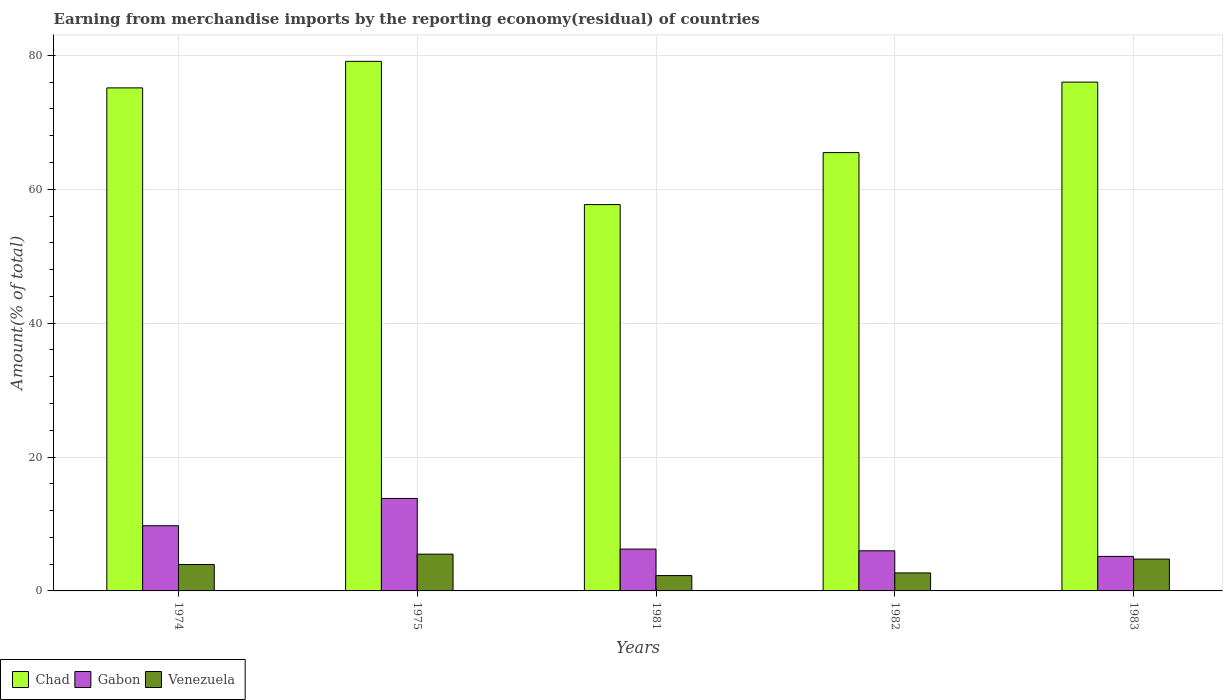How many groups of bars are there?
Offer a terse response. 5. Are the number of bars per tick equal to the number of legend labels?
Make the answer very short. Yes. How many bars are there on the 5th tick from the left?
Make the answer very short. 3. How many bars are there on the 4th tick from the right?
Offer a very short reply. 3. What is the label of the 4th group of bars from the left?
Your response must be concise. 1982. In how many cases, is the number of bars for a given year not equal to the number of legend labels?
Your response must be concise. 0. What is the percentage of amount earned from merchandise imports in Gabon in 1983?
Offer a terse response. 5.16. Across all years, what is the maximum percentage of amount earned from merchandise imports in Venezuela?
Give a very brief answer. 5.49. Across all years, what is the minimum percentage of amount earned from merchandise imports in Chad?
Give a very brief answer. 57.71. In which year was the percentage of amount earned from merchandise imports in Chad maximum?
Your answer should be very brief. 1975. What is the total percentage of amount earned from merchandise imports in Gabon in the graph?
Give a very brief answer. 40.95. What is the difference between the percentage of amount earned from merchandise imports in Chad in 1982 and that in 1983?
Give a very brief answer. -10.53. What is the difference between the percentage of amount earned from merchandise imports in Venezuela in 1975 and the percentage of amount earned from merchandise imports in Chad in 1983?
Keep it short and to the point. -70.51. What is the average percentage of amount earned from merchandise imports in Venezuela per year?
Give a very brief answer. 3.83. In the year 1982, what is the difference between the percentage of amount earned from merchandise imports in Gabon and percentage of amount earned from merchandise imports in Venezuela?
Provide a succinct answer. 3.3. What is the ratio of the percentage of amount earned from merchandise imports in Chad in 1981 to that in 1982?
Keep it short and to the point. 0.88. Is the difference between the percentage of amount earned from merchandise imports in Gabon in 1974 and 1981 greater than the difference between the percentage of amount earned from merchandise imports in Venezuela in 1974 and 1981?
Make the answer very short. Yes. What is the difference between the highest and the second highest percentage of amount earned from merchandise imports in Gabon?
Offer a terse response. 4.08. What is the difference between the highest and the lowest percentage of amount earned from merchandise imports in Venezuela?
Provide a short and direct response. 3.2. Is the sum of the percentage of amount earned from merchandise imports in Chad in 1974 and 1982 greater than the maximum percentage of amount earned from merchandise imports in Venezuela across all years?
Your response must be concise. Yes. What does the 3rd bar from the left in 1975 represents?
Offer a terse response. Venezuela. What does the 3rd bar from the right in 1981 represents?
Your response must be concise. Chad. How many bars are there?
Ensure brevity in your answer.  15. Are all the bars in the graph horizontal?
Offer a very short reply. No. How are the legend labels stacked?
Offer a terse response. Horizontal. What is the title of the graph?
Your answer should be very brief. Earning from merchandise imports by the reporting economy(residual) of countries. What is the label or title of the Y-axis?
Your answer should be very brief. Amount(% of total). What is the Amount(% of total) in Chad in 1974?
Your answer should be compact. 75.14. What is the Amount(% of total) in Gabon in 1974?
Your response must be concise. 9.74. What is the Amount(% of total) in Venezuela in 1974?
Offer a very short reply. 3.94. What is the Amount(% of total) of Chad in 1975?
Keep it short and to the point. 79.1. What is the Amount(% of total) of Gabon in 1975?
Your response must be concise. 13.81. What is the Amount(% of total) in Venezuela in 1975?
Give a very brief answer. 5.49. What is the Amount(% of total) in Chad in 1981?
Provide a succinct answer. 57.71. What is the Amount(% of total) of Gabon in 1981?
Give a very brief answer. 6.25. What is the Amount(% of total) of Venezuela in 1981?
Provide a succinct answer. 2.29. What is the Amount(% of total) in Chad in 1982?
Your answer should be very brief. 65.47. What is the Amount(% of total) in Gabon in 1982?
Provide a short and direct response. 5.99. What is the Amount(% of total) of Venezuela in 1982?
Give a very brief answer. 2.69. What is the Amount(% of total) in Chad in 1983?
Offer a very short reply. 76. What is the Amount(% of total) in Gabon in 1983?
Your answer should be compact. 5.16. What is the Amount(% of total) in Venezuela in 1983?
Make the answer very short. 4.75. Across all years, what is the maximum Amount(% of total) of Chad?
Your response must be concise. 79.1. Across all years, what is the maximum Amount(% of total) in Gabon?
Offer a terse response. 13.81. Across all years, what is the maximum Amount(% of total) of Venezuela?
Provide a short and direct response. 5.49. Across all years, what is the minimum Amount(% of total) in Chad?
Ensure brevity in your answer.  57.71. Across all years, what is the minimum Amount(% of total) of Gabon?
Your answer should be very brief. 5.16. Across all years, what is the minimum Amount(% of total) of Venezuela?
Your response must be concise. 2.29. What is the total Amount(% of total) of Chad in the graph?
Make the answer very short. 353.42. What is the total Amount(% of total) in Gabon in the graph?
Offer a very short reply. 40.95. What is the total Amount(% of total) of Venezuela in the graph?
Provide a short and direct response. 19.17. What is the difference between the Amount(% of total) in Chad in 1974 and that in 1975?
Your answer should be very brief. -3.96. What is the difference between the Amount(% of total) in Gabon in 1974 and that in 1975?
Give a very brief answer. -4.08. What is the difference between the Amount(% of total) in Venezuela in 1974 and that in 1975?
Offer a very short reply. -1.55. What is the difference between the Amount(% of total) of Chad in 1974 and that in 1981?
Your answer should be compact. 17.43. What is the difference between the Amount(% of total) in Gabon in 1974 and that in 1981?
Ensure brevity in your answer.  3.49. What is the difference between the Amount(% of total) of Venezuela in 1974 and that in 1981?
Make the answer very short. 1.65. What is the difference between the Amount(% of total) in Chad in 1974 and that in 1982?
Your answer should be compact. 9.67. What is the difference between the Amount(% of total) in Gabon in 1974 and that in 1982?
Your answer should be compact. 3.75. What is the difference between the Amount(% of total) in Venezuela in 1974 and that in 1982?
Provide a short and direct response. 1.26. What is the difference between the Amount(% of total) of Chad in 1974 and that in 1983?
Offer a terse response. -0.86. What is the difference between the Amount(% of total) in Gabon in 1974 and that in 1983?
Keep it short and to the point. 4.58. What is the difference between the Amount(% of total) of Venezuela in 1974 and that in 1983?
Keep it short and to the point. -0.81. What is the difference between the Amount(% of total) of Chad in 1975 and that in 1981?
Ensure brevity in your answer.  21.39. What is the difference between the Amount(% of total) in Gabon in 1975 and that in 1981?
Give a very brief answer. 7.56. What is the difference between the Amount(% of total) of Venezuela in 1975 and that in 1981?
Your answer should be very brief. 3.2. What is the difference between the Amount(% of total) in Chad in 1975 and that in 1982?
Your response must be concise. 13.63. What is the difference between the Amount(% of total) of Gabon in 1975 and that in 1982?
Ensure brevity in your answer.  7.82. What is the difference between the Amount(% of total) of Venezuela in 1975 and that in 1982?
Ensure brevity in your answer.  2.81. What is the difference between the Amount(% of total) of Chad in 1975 and that in 1983?
Your answer should be compact. 3.1. What is the difference between the Amount(% of total) in Gabon in 1975 and that in 1983?
Offer a terse response. 8.66. What is the difference between the Amount(% of total) in Venezuela in 1975 and that in 1983?
Your answer should be very brief. 0.74. What is the difference between the Amount(% of total) of Chad in 1981 and that in 1982?
Your answer should be very brief. -7.76. What is the difference between the Amount(% of total) in Gabon in 1981 and that in 1982?
Ensure brevity in your answer.  0.26. What is the difference between the Amount(% of total) of Venezuela in 1981 and that in 1982?
Offer a very short reply. -0.4. What is the difference between the Amount(% of total) in Chad in 1981 and that in 1983?
Offer a terse response. -18.29. What is the difference between the Amount(% of total) of Gabon in 1981 and that in 1983?
Provide a succinct answer. 1.09. What is the difference between the Amount(% of total) in Venezuela in 1981 and that in 1983?
Your response must be concise. -2.46. What is the difference between the Amount(% of total) in Chad in 1982 and that in 1983?
Provide a short and direct response. -10.53. What is the difference between the Amount(% of total) in Gabon in 1982 and that in 1983?
Ensure brevity in your answer.  0.83. What is the difference between the Amount(% of total) in Venezuela in 1982 and that in 1983?
Provide a short and direct response. -2.07. What is the difference between the Amount(% of total) in Chad in 1974 and the Amount(% of total) in Gabon in 1975?
Provide a short and direct response. 61.32. What is the difference between the Amount(% of total) in Chad in 1974 and the Amount(% of total) in Venezuela in 1975?
Keep it short and to the point. 69.65. What is the difference between the Amount(% of total) of Gabon in 1974 and the Amount(% of total) of Venezuela in 1975?
Provide a succinct answer. 4.25. What is the difference between the Amount(% of total) of Chad in 1974 and the Amount(% of total) of Gabon in 1981?
Offer a very short reply. 68.89. What is the difference between the Amount(% of total) in Chad in 1974 and the Amount(% of total) in Venezuela in 1981?
Your response must be concise. 72.85. What is the difference between the Amount(% of total) of Gabon in 1974 and the Amount(% of total) of Venezuela in 1981?
Make the answer very short. 7.45. What is the difference between the Amount(% of total) of Chad in 1974 and the Amount(% of total) of Gabon in 1982?
Provide a short and direct response. 69.15. What is the difference between the Amount(% of total) in Chad in 1974 and the Amount(% of total) in Venezuela in 1982?
Provide a short and direct response. 72.45. What is the difference between the Amount(% of total) of Gabon in 1974 and the Amount(% of total) of Venezuela in 1982?
Offer a terse response. 7.05. What is the difference between the Amount(% of total) in Chad in 1974 and the Amount(% of total) in Gabon in 1983?
Make the answer very short. 69.98. What is the difference between the Amount(% of total) of Chad in 1974 and the Amount(% of total) of Venezuela in 1983?
Provide a short and direct response. 70.39. What is the difference between the Amount(% of total) of Gabon in 1974 and the Amount(% of total) of Venezuela in 1983?
Ensure brevity in your answer.  4.99. What is the difference between the Amount(% of total) in Chad in 1975 and the Amount(% of total) in Gabon in 1981?
Make the answer very short. 72.85. What is the difference between the Amount(% of total) of Chad in 1975 and the Amount(% of total) of Venezuela in 1981?
Offer a very short reply. 76.81. What is the difference between the Amount(% of total) of Gabon in 1975 and the Amount(% of total) of Venezuela in 1981?
Keep it short and to the point. 11.52. What is the difference between the Amount(% of total) in Chad in 1975 and the Amount(% of total) in Gabon in 1982?
Offer a very short reply. 73.11. What is the difference between the Amount(% of total) in Chad in 1975 and the Amount(% of total) in Venezuela in 1982?
Ensure brevity in your answer.  76.42. What is the difference between the Amount(% of total) of Gabon in 1975 and the Amount(% of total) of Venezuela in 1982?
Offer a terse response. 11.13. What is the difference between the Amount(% of total) of Chad in 1975 and the Amount(% of total) of Gabon in 1983?
Keep it short and to the point. 73.95. What is the difference between the Amount(% of total) of Chad in 1975 and the Amount(% of total) of Venezuela in 1983?
Offer a terse response. 74.35. What is the difference between the Amount(% of total) in Gabon in 1975 and the Amount(% of total) in Venezuela in 1983?
Your answer should be compact. 9.06. What is the difference between the Amount(% of total) in Chad in 1981 and the Amount(% of total) in Gabon in 1982?
Your response must be concise. 51.72. What is the difference between the Amount(% of total) of Chad in 1981 and the Amount(% of total) of Venezuela in 1982?
Your response must be concise. 55.02. What is the difference between the Amount(% of total) in Gabon in 1981 and the Amount(% of total) in Venezuela in 1982?
Provide a succinct answer. 3.56. What is the difference between the Amount(% of total) in Chad in 1981 and the Amount(% of total) in Gabon in 1983?
Give a very brief answer. 52.55. What is the difference between the Amount(% of total) of Chad in 1981 and the Amount(% of total) of Venezuela in 1983?
Offer a terse response. 52.96. What is the difference between the Amount(% of total) of Gabon in 1981 and the Amount(% of total) of Venezuela in 1983?
Offer a terse response. 1.5. What is the difference between the Amount(% of total) in Chad in 1982 and the Amount(% of total) in Gabon in 1983?
Your response must be concise. 60.32. What is the difference between the Amount(% of total) in Chad in 1982 and the Amount(% of total) in Venezuela in 1983?
Ensure brevity in your answer.  60.72. What is the difference between the Amount(% of total) of Gabon in 1982 and the Amount(% of total) of Venezuela in 1983?
Your answer should be compact. 1.24. What is the average Amount(% of total) of Chad per year?
Your response must be concise. 70.68. What is the average Amount(% of total) in Gabon per year?
Offer a very short reply. 8.19. What is the average Amount(% of total) of Venezuela per year?
Provide a succinct answer. 3.83. In the year 1974, what is the difference between the Amount(% of total) in Chad and Amount(% of total) in Gabon?
Offer a terse response. 65.4. In the year 1974, what is the difference between the Amount(% of total) of Chad and Amount(% of total) of Venezuela?
Give a very brief answer. 71.2. In the year 1974, what is the difference between the Amount(% of total) in Gabon and Amount(% of total) in Venezuela?
Provide a succinct answer. 5.8. In the year 1975, what is the difference between the Amount(% of total) in Chad and Amount(% of total) in Gabon?
Offer a very short reply. 65.29. In the year 1975, what is the difference between the Amount(% of total) in Chad and Amount(% of total) in Venezuela?
Keep it short and to the point. 73.61. In the year 1975, what is the difference between the Amount(% of total) of Gabon and Amount(% of total) of Venezuela?
Offer a terse response. 8.32. In the year 1981, what is the difference between the Amount(% of total) in Chad and Amount(% of total) in Gabon?
Ensure brevity in your answer.  51.46. In the year 1981, what is the difference between the Amount(% of total) in Chad and Amount(% of total) in Venezuela?
Your answer should be compact. 55.42. In the year 1981, what is the difference between the Amount(% of total) in Gabon and Amount(% of total) in Venezuela?
Provide a succinct answer. 3.96. In the year 1982, what is the difference between the Amount(% of total) in Chad and Amount(% of total) in Gabon?
Give a very brief answer. 59.48. In the year 1982, what is the difference between the Amount(% of total) in Chad and Amount(% of total) in Venezuela?
Give a very brief answer. 62.79. In the year 1982, what is the difference between the Amount(% of total) of Gabon and Amount(% of total) of Venezuela?
Keep it short and to the point. 3.3. In the year 1983, what is the difference between the Amount(% of total) of Chad and Amount(% of total) of Gabon?
Make the answer very short. 70.84. In the year 1983, what is the difference between the Amount(% of total) in Chad and Amount(% of total) in Venezuela?
Offer a very short reply. 71.25. In the year 1983, what is the difference between the Amount(% of total) in Gabon and Amount(% of total) in Venezuela?
Offer a terse response. 0.4. What is the ratio of the Amount(% of total) in Chad in 1974 to that in 1975?
Keep it short and to the point. 0.95. What is the ratio of the Amount(% of total) of Gabon in 1974 to that in 1975?
Offer a terse response. 0.7. What is the ratio of the Amount(% of total) of Venezuela in 1974 to that in 1975?
Your response must be concise. 0.72. What is the ratio of the Amount(% of total) of Chad in 1974 to that in 1981?
Give a very brief answer. 1.3. What is the ratio of the Amount(% of total) in Gabon in 1974 to that in 1981?
Your response must be concise. 1.56. What is the ratio of the Amount(% of total) in Venezuela in 1974 to that in 1981?
Give a very brief answer. 1.72. What is the ratio of the Amount(% of total) of Chad in 1974 to that in 1982?
Offer a very short reply. 1.15. What is the ratio of the Amount(% of total) in Gabon in 1974 to that in 1982?
Keep it short and to the point. 1.63. What is the ratio of the Amount(% of total) in Venezuela in 1974 to that in 1982?
Ensure brevity in your answer.  1.47. What is the ratio of the Amount(% of total) of Chad in 1974 to that in 1983?
Your answer should be very brief. 0.99. What is the ratio of the Amount(% of total) in Gabon in 1974 to that in 1983?
Your answer should be very brief. 1.89. What is the ratio of the Amount(% of total) of Venezuela in 1974 to that in 1983?
Offer a terse response. 0.83. What is the ratio of the Amount(% of total) of Chad in 1975 to that in 1981?
Your response must be concise. 1.37. What is the ratio of the Amount(% of total) of Gabon in 1975 to that in 1981?
Offer a terse response. 2.21. What is the ratio of the Amount(% of total) in Venezuela in 1975 to that in 1981?
Offer a terse response. 2.4. What is the ratio of the Amount(% of total) of Chad in 1975 to that in 1982?
Offer a very short reply. 1.21. What is the ratio of the Amount(% of total) in Gabon in 1975 to that in 1982?
Ensure brevity in your answer.  2.31. What is the ratio of the Amount(% of total) in Venezuela in 1975 to that in 1982?
Give a very brief answer. 2.04. What is the ratio of the Amount(% of total) of Chad in 1975 to that in 1983?
Keep it short and to the point. 1.04. What is the ratio of the Amount(% of total) of Gabon in 1975 to that in 1983?
Provide a short and direct response. 2.68. What is the ratio of the Amount(% of total) in Venezuela in 1975 to that in 1983?
Offer a very short reply. 1.16. What is the ratio of the Amount(% of total) of Chad in 1981 to that in 1982?
Keep it short and to the point. 0.88. What is the ratio of the Amount(% of total) in Gabon in 1981 to that in 1982?
Give a very brief answer. 1.04. What is the ratio of the Amount(% of total) in Venezuela in 1981 to that in 1982?
Make the answer very short. 0.85. What is the ratio of the Amount(% of total) in Chad in 1981 to that in 1983?
Ensure brevity in your answer.  0.76. What is the ratio of the Amount(% of total) of Gabon in 1981 to that in 1983?
Provide a short and direct response. 1.21. What is the ratio of the Amount(% of total) of Venezuela in 1981 to that in 1983?
Your answer should be very brief. 0.48. What is the ratio of the Amount(% of total) of Chad in 1982 to that in 1983?
Offer a terse response. 0.86. What is the ratio of the Amount(% of total) of Gabon in 1982 to that in 1983?
Provide a succinct answer. 1.16. What is the ratio of the Amount(% of total) in Venezuela in 1982 to that in 1983?
Your answer should be very brief. 0.57. What is the difference between the highest and the second highest Amount(% of total) of Chad?
Your answer should be compact. 3.1. What is the difference between the highest and the second highest Amount(% of total) in Gabon?
Your answer should be very brief. 4.08. What is the difference between the highest and the second highest Amount(% of total) in Venezuela?
Give a very brief answer. 0.74. What is the difference between the highest and the lowest Amount(% of total) in Chad?
Your answer should be compact. 21.39. What is the difference between the highest and the lowest Amount(% of total) of Gabon?
Your answer should be compact. 8.66. What is the difference between the highest and the lowest Amount(% of total) in Venezuela?
Make the answer very short. 3.2. 